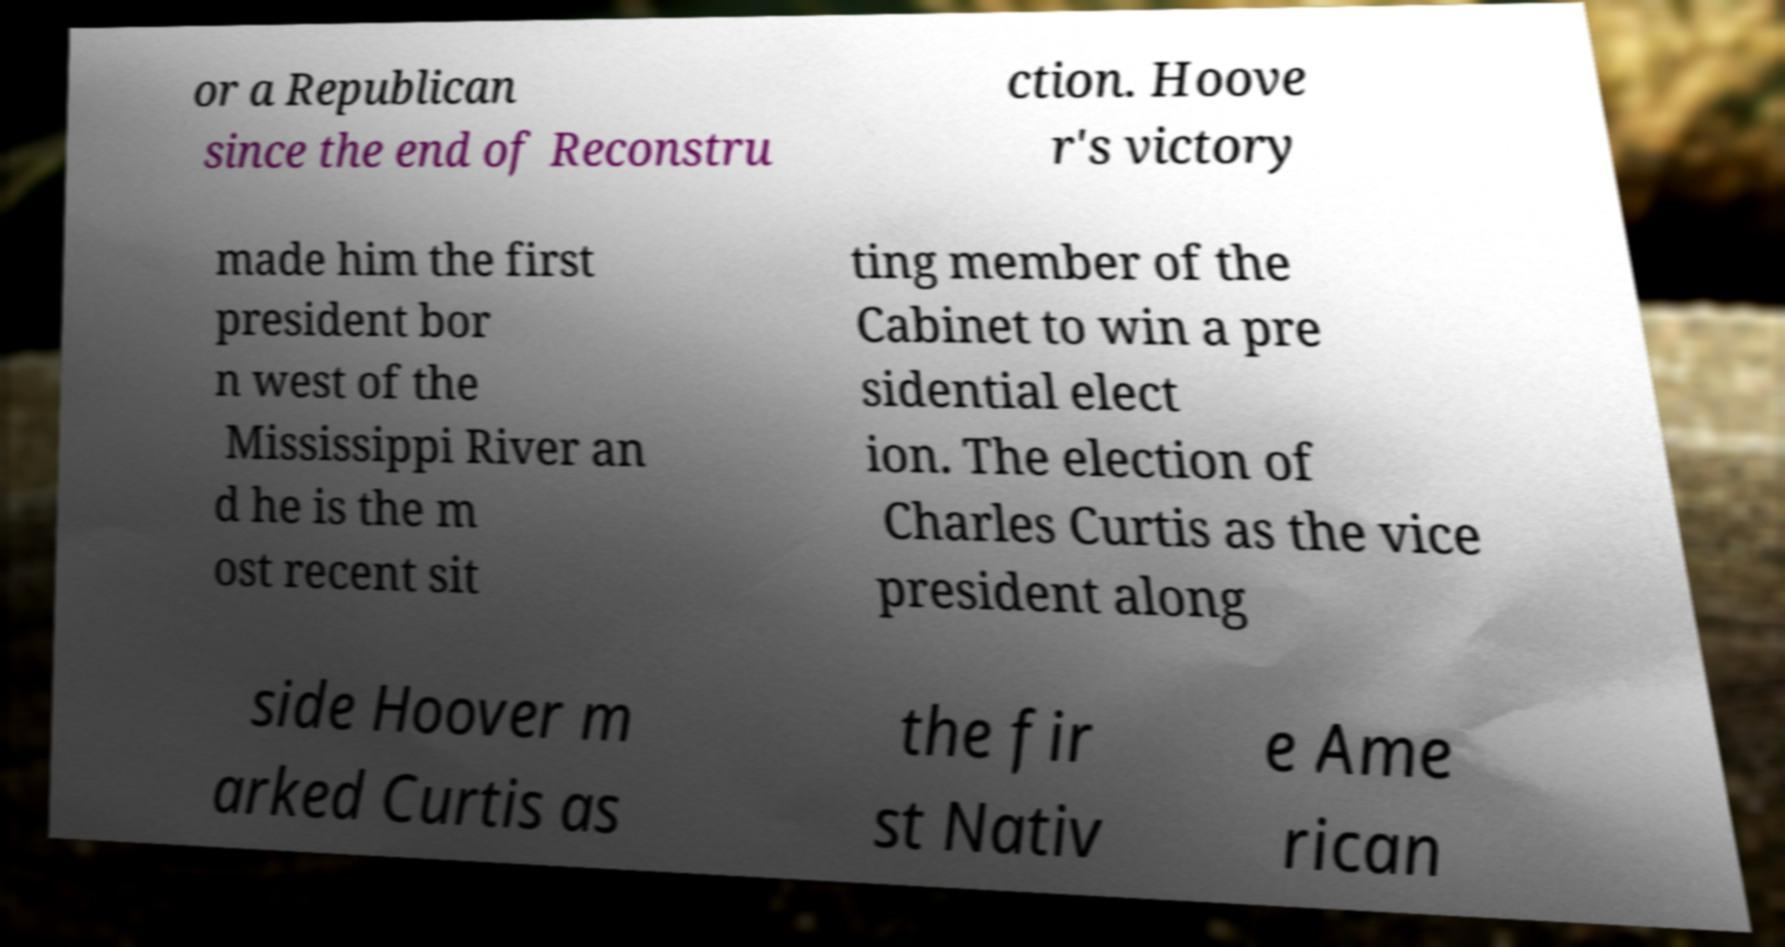What messages or text are displayed in this image? I need them in a readable, typed format. or a Republican since the end of Reconstru ction. Hoove r's victory made him the first president bor n west of the Mississippi River an d he is the m ost recent sit ting member of the Cabinet to win a pre sidential elect ion. The election of Charles Curtis as the vice president along side Hoover m arked Curtis as the fir st Nativ e Ame rican 